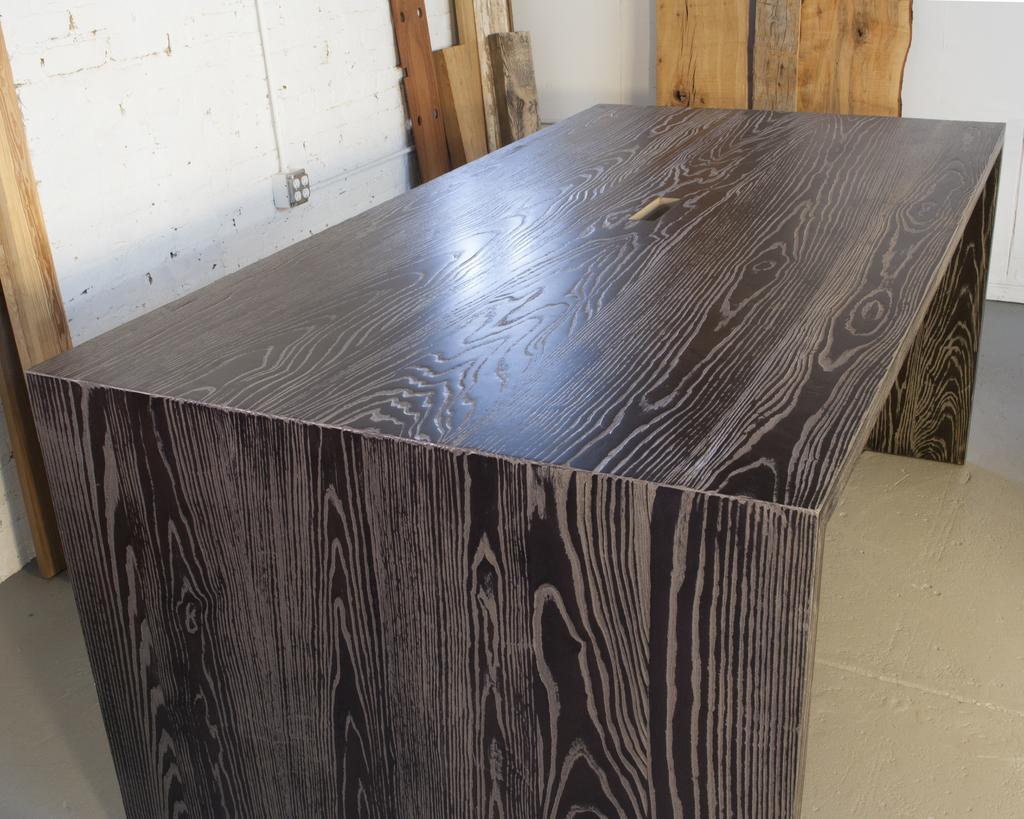Describe this image in one or two sentences. In this picture we can see table on the floor, wall and wooden objects. 